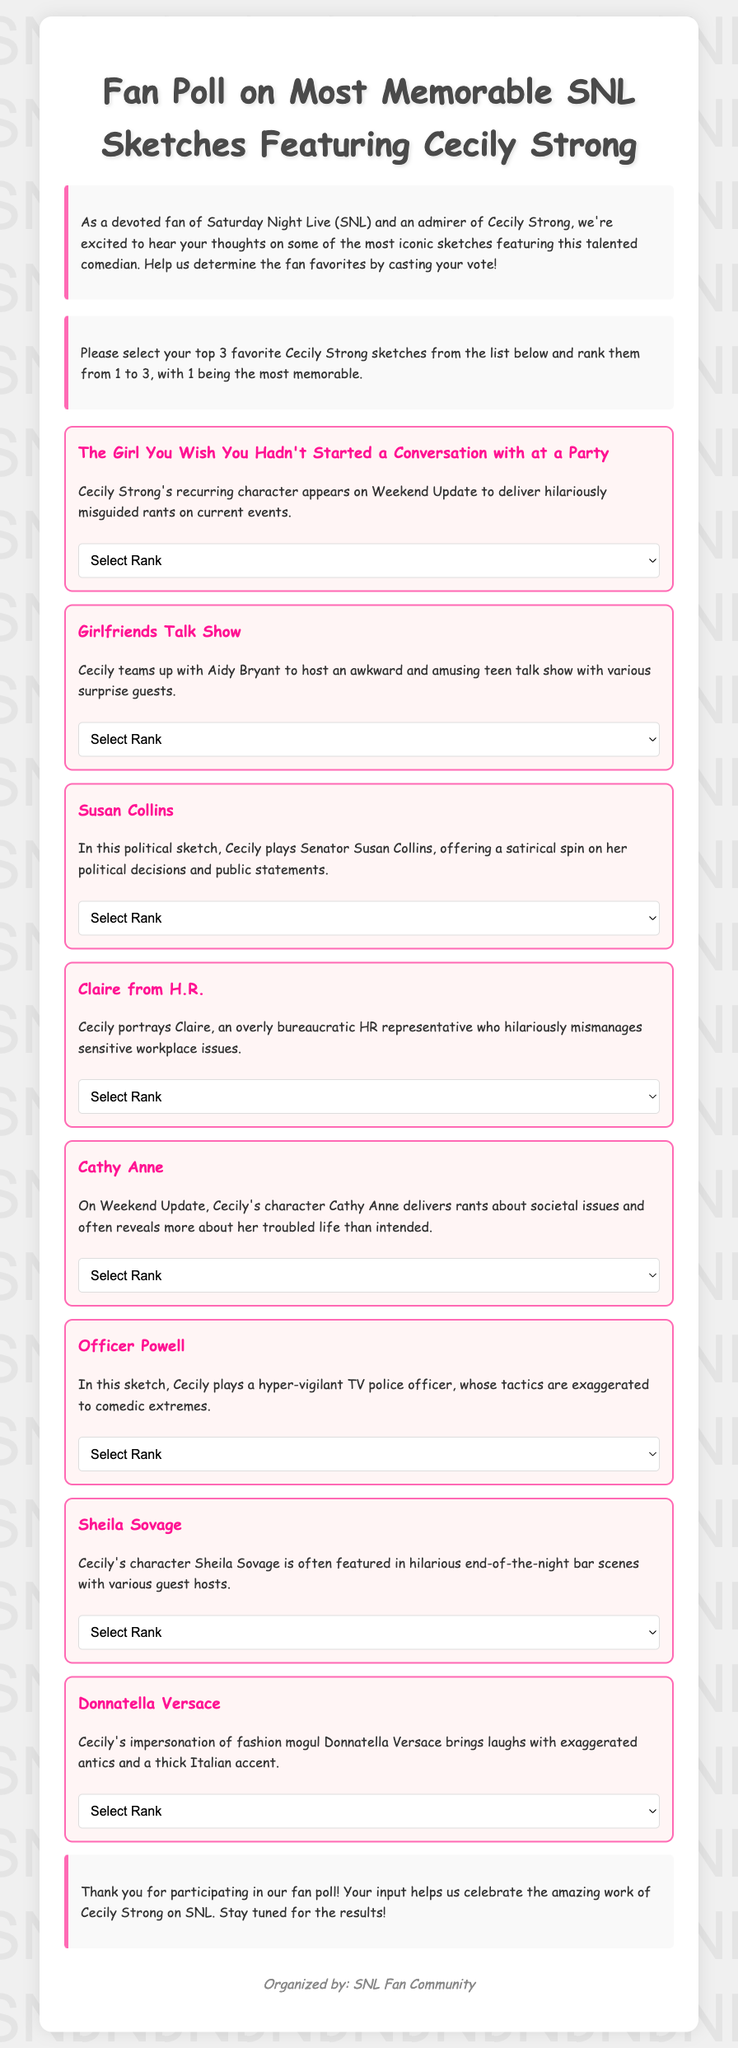What is the title of the poll? The title of the poll is prominently displayed at the top of the document, stating its focus on Cecily Strong's memorable sketches.
Answer: Fan Poll on Most Memorable SNL Sketches Featuring Cecily Strong How many sketches are listed in the document? There are a total of eight sketches presented in the document for voting.
Answer: 8 What character does Cecily Strong portray in the sketch "The Girl You Wish You Hadn't Started a Conversation with at a Party"? The character description for this sketch reveals that Cecily portrays a character delivering misguided rants.
Answer: Hilariously misguided rants Which sketch features Cecily Strong alongside Aidy Bryant? The document specifies that in "Girlfriends Talk Show," Cecily teams up with Aidy Bryant.
Answer: Girlfriends Talk Show What is the ranking system used in the poll? The document explains the ranking system where participants rank their top choices from 1 to 3, with 1 being the most memorable.
Answer: 1 to 3 What color is used for the border of the sketch boxes? The text in the document specifies the color of the border around the sketches as pink, referred to as "hot pink" in stylistic terms.
Answer: Pink Which character delivers societal issue rants in Weekend Update? The document identifies that Cecily's character Cathy Anne delivers rants about societal issues on Weekend Update.
Answer: Cathy Anne Who organized the fan poll? The credits section of the document clearly states who organized the poll for SNL fans.
Answer: SNL Fan Community 